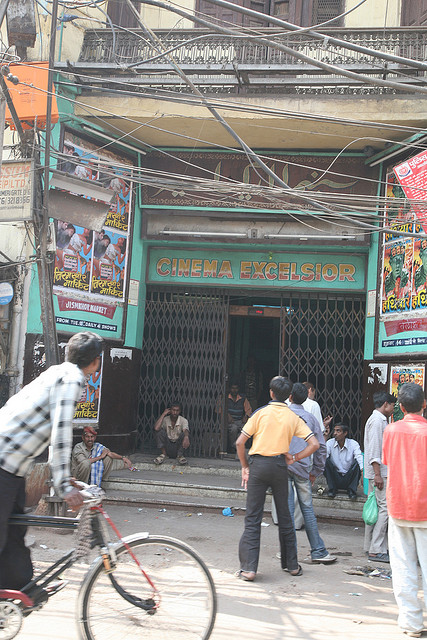What impact might the tangled electrical wires above the cinema have on its operations? The tangled electrical wires above 'CINEMA EXCELSIOR' are quite typical in dense urban settings and could have multiple impacts on its operations. They might occasionally lead to power issues, such as outages or fluctuations, which could disrupt movie screenings. However, this visual tangle also speaks to the resourcefulness and adaptability of the area, with the cinema likely having backup solutions in place to handle such interruptions. The wires might add to the overall rugged charm of the establishment, highlighting it as a resilient fixture in a busy urban environment. Imagine if the cinema could transport moviegoers into the movie itself. What might this experience be like? Imagine stepping into 'CINEMA EXCELSIOR' and finding yourself not just watching a movie, but living it. As the lights dim, you’re suddenly transported onto the vibrant streets of a Bollywood musical, dancing and singing along with the stars. Or perhaps you find yourself in the midst of an epic battle scene, feeling the rush of adrenaline as you swing a sword alongside the hero. This immersive experience would blend the lines between audience and film, allowing moviegoers to become part of the story, exploring fantastical worlds and high-stakes adventures first-hand. The charm and nostalgia of the cinema would now pair with the thrill of living the cinema's magic in real-time. 